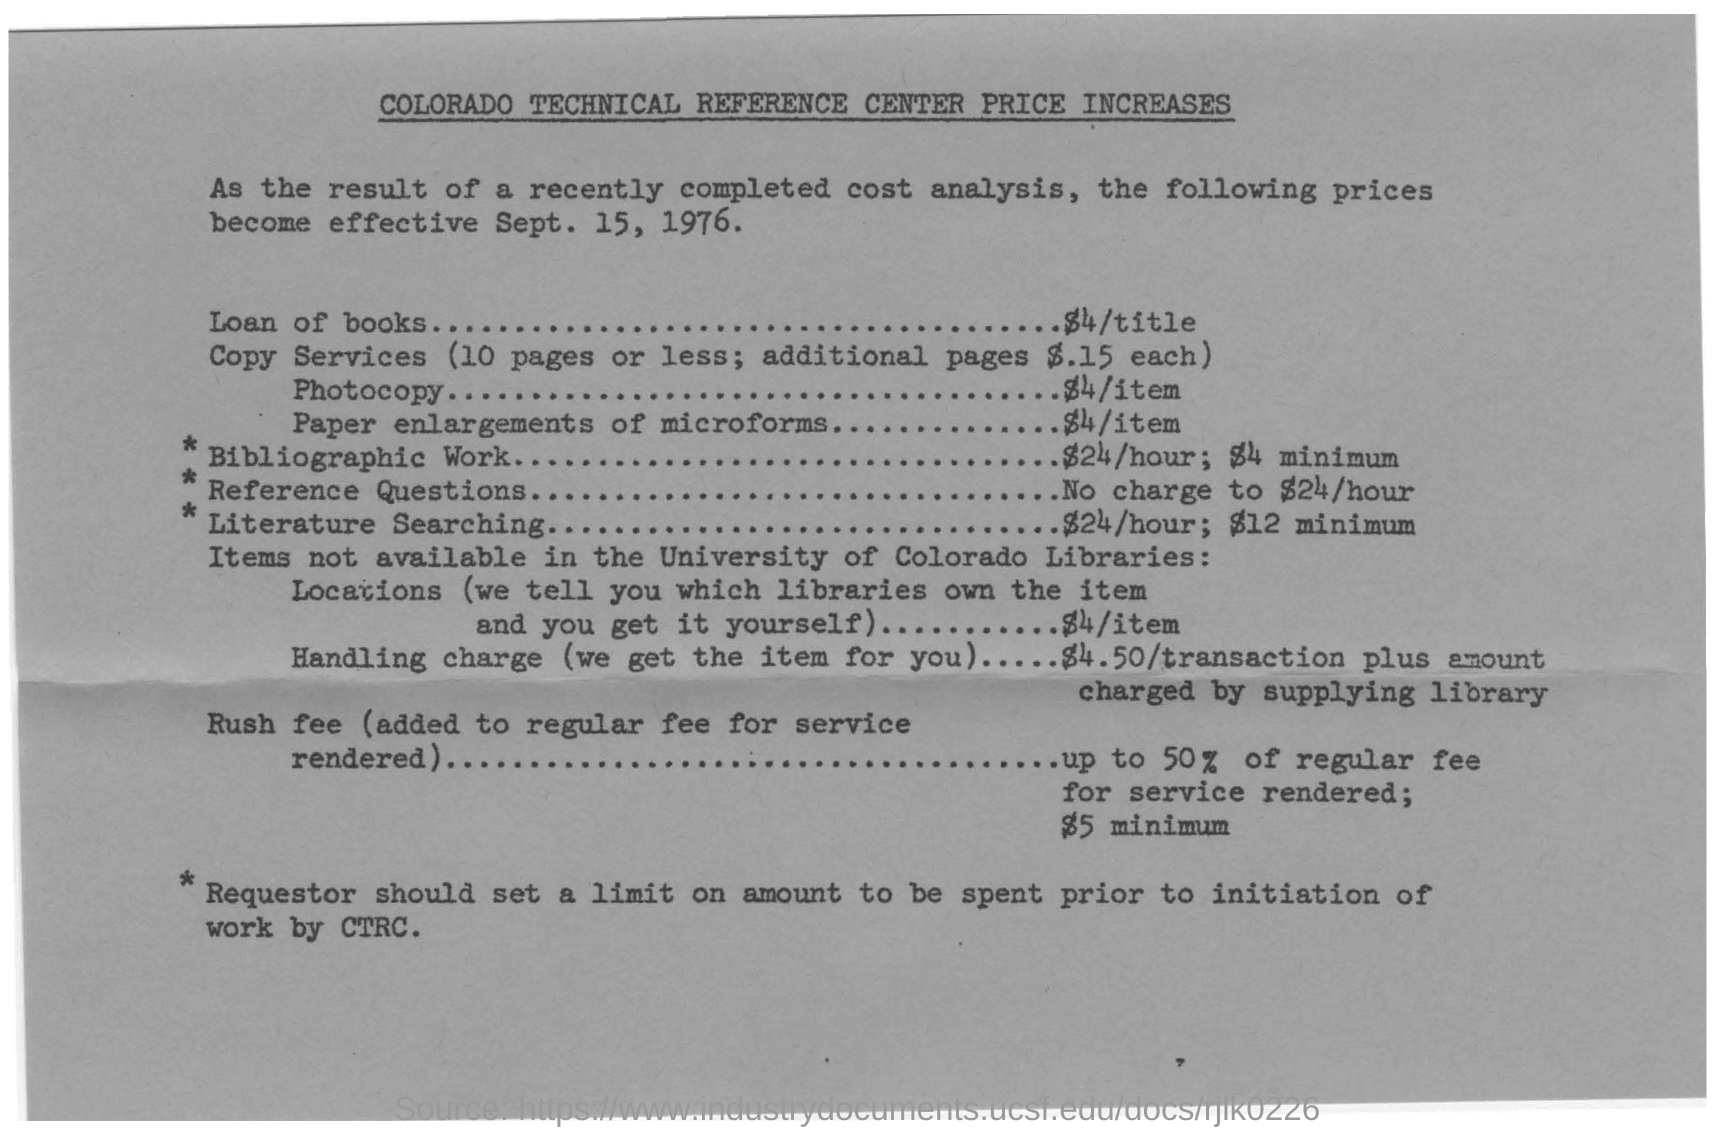Give some essential details in this illustration. The title of the document is "Colorado Technical Reference Center Price Increases. The date on the bill is September 15, 1976. The cost of a photocopy is 4$/item. The cost of borrowing books is $4 per title. 